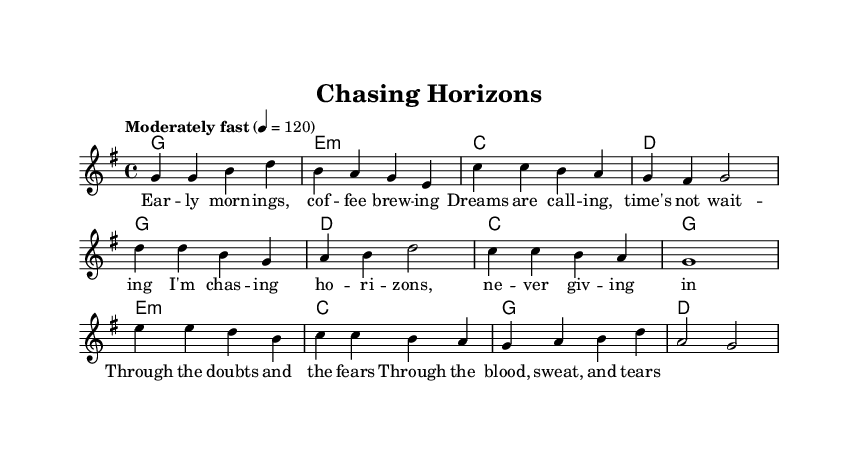What is the key signature of this music? The key signature is G major, which has one sharp (F#). This is indicated at the beginning of the staff.
Answer: G major What is the time signature of this music? The time signature is 4/4, which means there are four beats in a measure and the quarter note gets one beat. This is shown at the beginning of the score.
Answer: 4/4 What is the tempo marking of this piece? The tempo marking is "Moderately fast," with a metronome marking indicating 120 beats per minute. This is noted above the staff at the beginning.
Answer: Moderately fast How many measures are in the verse section? The verse section contains four measures as indicated by the grouping of notes before the chorus section starts. Each set is separated by a vertical line.
Answer: Four What chords are used in the bridge section? The chords used in the bridge section are E minor, C major, G major, and D major, as indicated in the chord mode notation below the melody.
Answer: E minor, C, G, D What lyrical theme is present in the chorus? The lyrical theme in the chorus reflects perseverance and determination, as evidenced by the text "I'm chasing horizons, never giving in," indicating a motivational message.
Answer: Perseverance How many different sections does the piece have? The piece has three distinct sections: verse, chorus, and bridge, which are all labeled in the score. Counting these, there are three main parts.
Answer: Three 